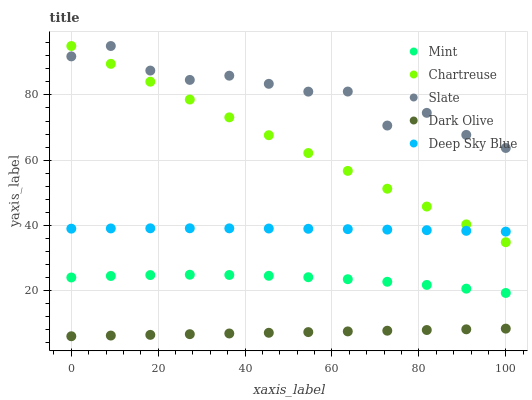Does Dark Olive have the minimum area under the curve?
Answer yes or no. Yes. Does Slate have the maximum area under the curve?
Answer yes or no. Yes. Does Mint have the minimum area under the curve?
Answer yes or no. No. Does Mint have the maximum area under the curve?
Answer yes or no. No. Is Dark Olive the smoothest?
Answer yes or no. Yes. Is Slate the roughest?
Answer yes or no. Yes. Is Mint the smoothest?
Answer yes or no. No. Is Mint the roughest?
Answer yes or no. No. Does Dark Olive have the lowest value?
Answer yes or no. Yes. Does Mint have the lowest value?
Answer yes or no. No. Does Slate have the highest value?
Answer yes or no. Yes. Does Mint have the highest value?
Answer yes or no. No. Is Deep Sky Blue less than Slate?
Answer yes or no. Yes. Is Deep Sky Blue greater than Dark Olive?
Answer yes or no. Yes. Does Slate intersect Chartreuse?
Answer yes or no. Yes. Is Slate less than Chartreuse?
Answer yes or no. No. Is Slate greater than Chartreuse?
Answer yes or no. No. Does Deep Sky Blue intersect Slate?
Answer yes or no. No. 